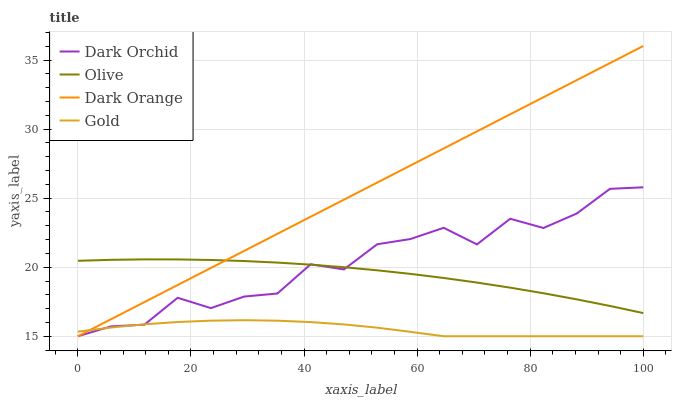Does Gold have the minimum area under the curve?
Answer yes or no. Yes. Does Dark Orange have the maximum area under the curve?
Answer yes or no. Yes. Does Dark Orange have the minimum area under the curve?
Answer yes or no. No. Does Gold have the maximum area under the curve?
Answer yes or no. No. Is Dark Orange the smoothest?
Answer yes or no. Yes. Is Dark Orchid the roughest?
Answer yes or no. Yes. Is Gold the smoothest?
Answer yes or no. No. Is Gold the roughest?
Answer yes or no. No. Does Dark Orange have the lowest value?
Answer yes or no. Yes. Does Dark Orange have the highest value?
Answer yes or no. Yes. Does Gold have the highest value?
Answer yes or no. No. Is Gold less than Olive?
Answer yes or no. Yes. Is Olive greater than Gold?
Answer yes or no. Yes. Does Dark Orange intersect Gold?
Answer yes or no. Yes. Is Dark Orange less than Gold?
Answer yes or no. No. Is Dark Orange greater than Gold?
Answer yes or no. No. Does Gold intersect Olive?
Answer yes or no. No. 